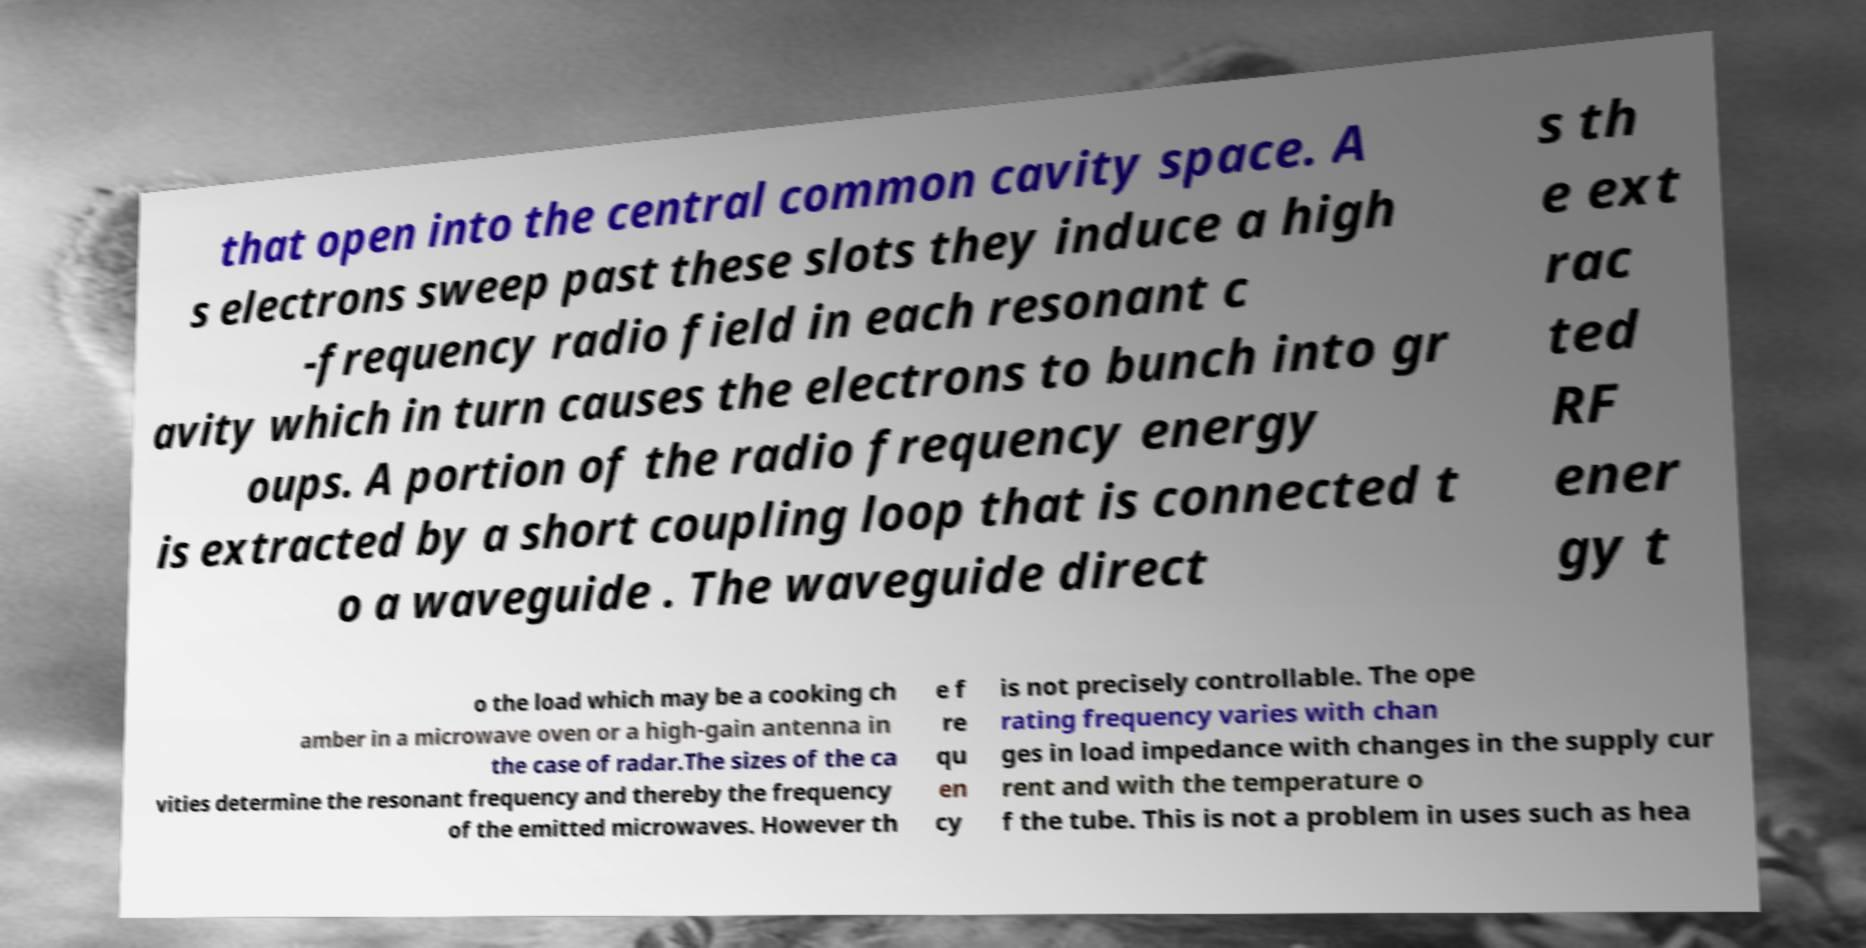Can you accurately transcribe the text from the provided image for me? that open into the central common cavity space. A s electrons sweep past these slots they induce a high -frequency radio field in each resonant c avity which in turn causes the electrons to bunch into gr oups. A portion of the radio frequency energy is extracted by a short coupling loop that is connected t o a waveguide . The waveguide direct s th e ext rac ted RF ener gy t o the load which may be a cooking ch amber in a microwave oven or a high-gain antenna in the case of radar.The sizes of the ca vities determine the resonant frequency and thereby the frequency of the emitted microwaves. However th e f re qu en cy is not precisely controllable. The ope rating frequency varies with chan ges in load impedance with changes in the supply cur rent and with the temperature o f the tube. This is not a problem in uses such as hea 